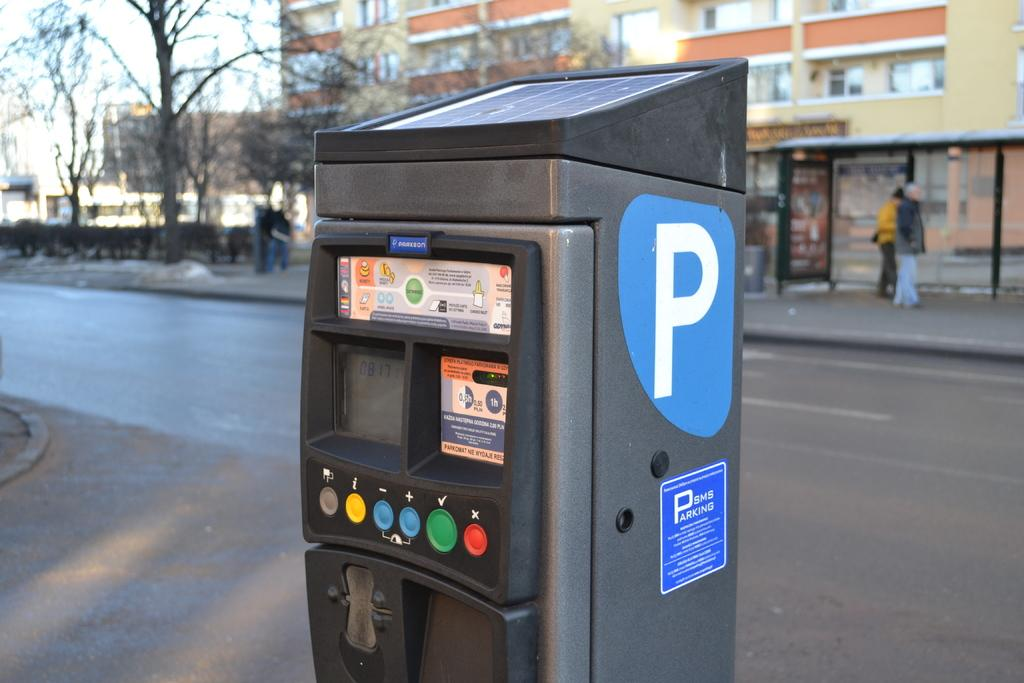<image>
Provide a brief description of the given image. A SMS Parking kiosk with payment options for one half hour and one hour. 